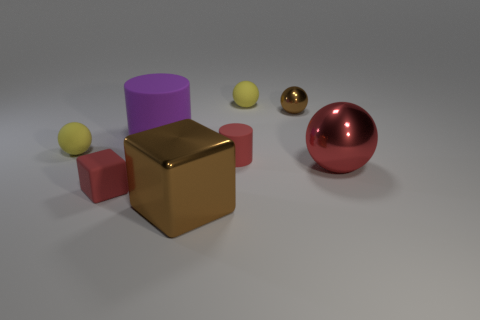Add 1 small yellow balls. How many objects exist? 9 Subtract all brown spheres. How many spheres are left? 3 Subtract 1 cylinders. How many cylinders are left? 1 Subtract all red cylinders. How many cylinders are left? 1 Subtract 1 brown cubes. How many objects are left? 7 Subtract all cylinders. How many objects are left? 6 Subtract all cyan cylinders. Subtract all green spheres. How many cylinders are left? 2 Subtract all purple cylinders. How many yellow balls are left? 2 Subtract all tiny cylinders. Subtract all cyan spheres. How many objects are left? 7 Add 5 large brown things. How many large brown things are left? 6 